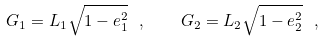<formula> <loc_0><loc_0><loc_500><loc_500>G _ { 1 } = L _ { 1 } \sqrt { 1 - e _ { 1 } ^ { 2 } } \ , \quad G _ { 2 } = L _ { 2 } \sqrt { 1 - e _ { 2 } ^ { 2 } } \ ,</formula> 